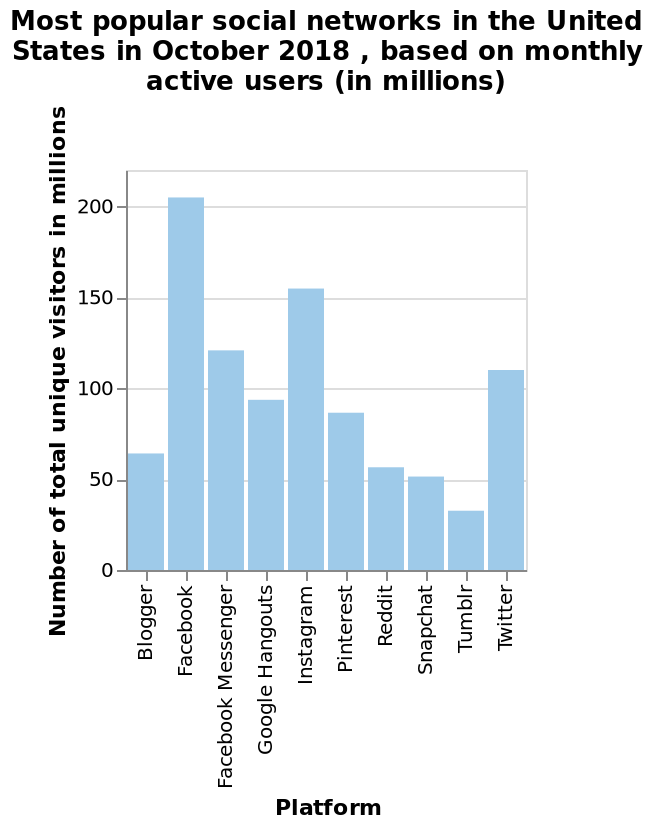<image>
What information did the bar chart provide about the popularity of different social platforms? The bar chart indicated that Facebook was the most popular platform, surpassing all competition, while Tumblr and Snapchat had significantly lower popularity in terms of user numbers. What is the total number of unique visitors on Instagram in October 2018? The total number of unique visitors on Instagram in October 2018 is not provided in the given information. Which social media platform did travel companies in the United States use the most in the first quarter of 2014?  Facebook Which social media platforms had low user numbers in comparison to the other platforms? Tumblr and Snapchat had low amounts of users in comparison to the rest of the social platforms. Are there any other social networks mentioned in the figure? No, only the platforms from Blogger to Twitter are mentioned in the figure. What is the most popular social network in the United States in October 2018 based on monthly active users? Twitter is the most popular social network in the United States in October 2018 based on monthly active users. 